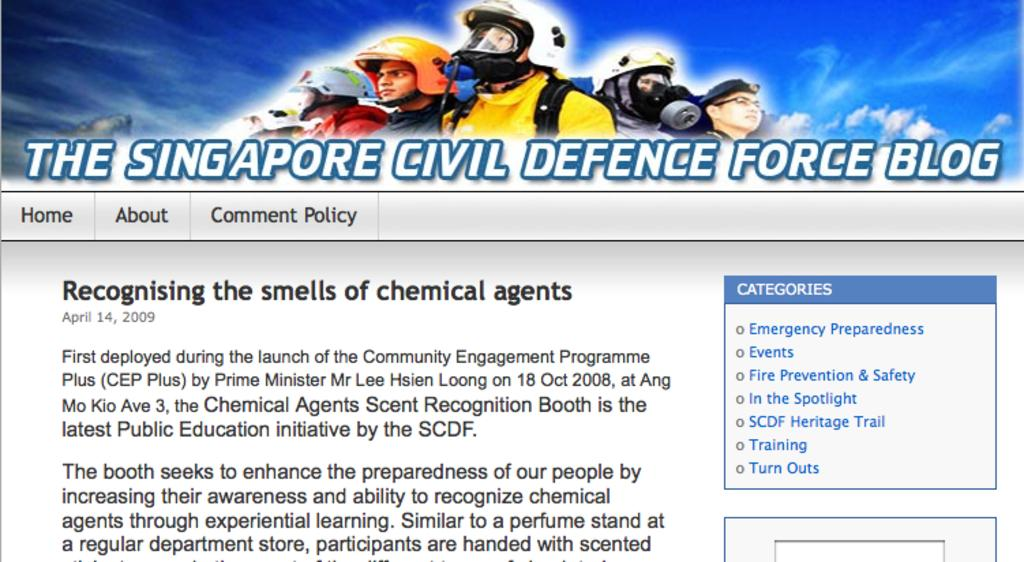What is the main subject of the image? The main subject of the image is a blog. What type of content is included in the blog? The blog contains an image and words. Are there any numerical elements in the blog? Yes, there are numbers in the blog. What type of creature can be seen playing with a friend in the afternoon in the image? There is no creature or friend present in the image, and the time of day is not mentioned. 